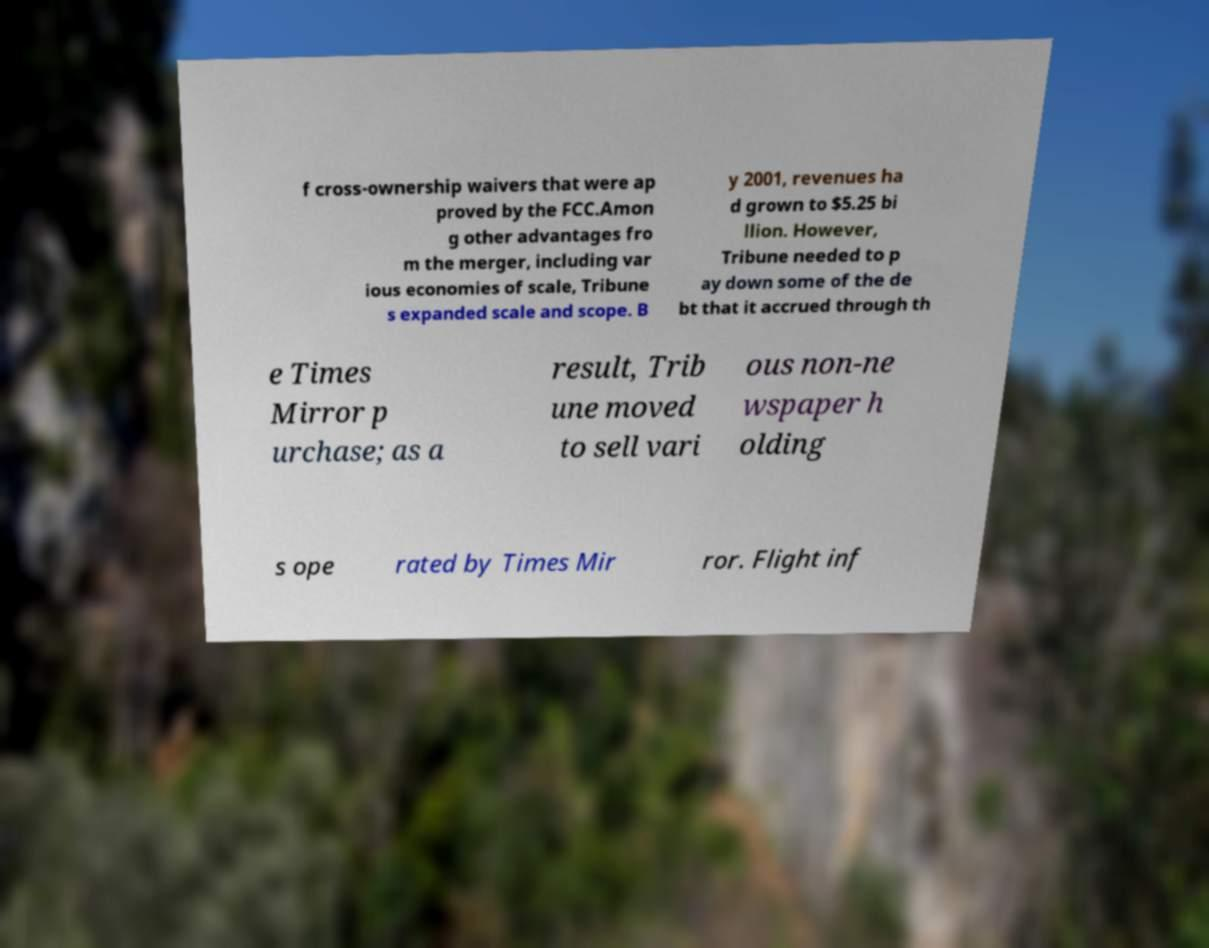For documentation purposes, I need the text within this image transcribed. Could you provide that? f cross-ownership waivers that were ap proved by the FCC.Amon g other advantages fro m the merger, including var ious economies of scale, Tribune s expanded scale and scope. B y 2001, revenues ha d grown to $5.25 bi llion. However, Tribune needed to p ay down some of the de bt that it accrued through th e Times Mirror p urchase; as a result, Trib une moved to sell vari ous non-ne wspaper h olding s ope rated by Times Mir ror. Flight inf 